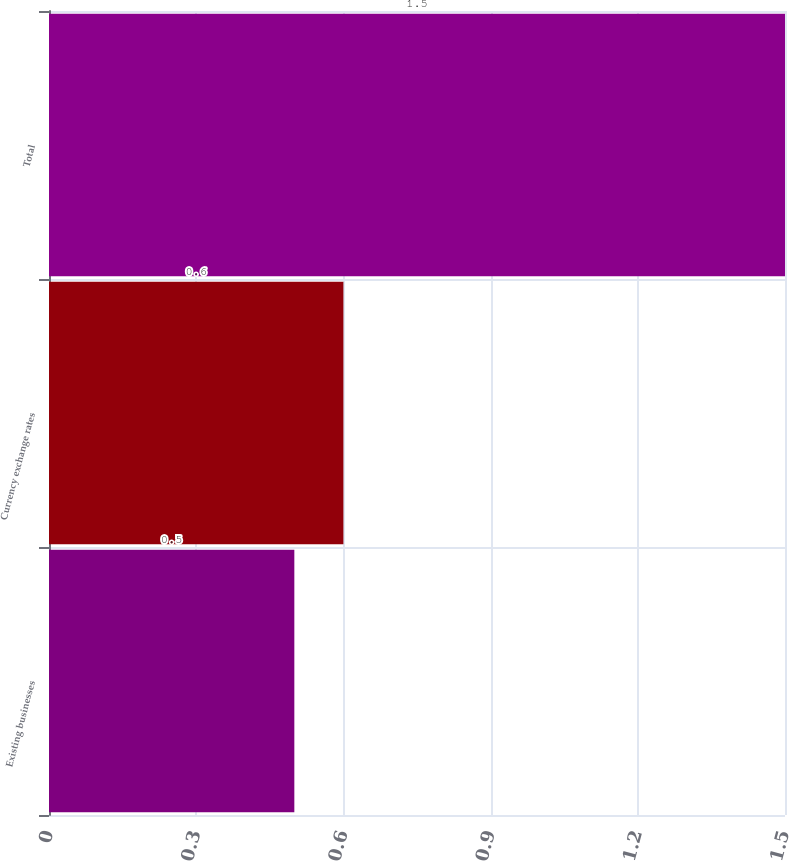<chart> <loc_0><loc_0><loc_500><loc_500><bar_chart><fcel>Existing businesses<fcel>Currency exchange rates<fcel>Total<nl><fcel>0.5<fcel>0.6<fcel>1.5<nl></chart> 